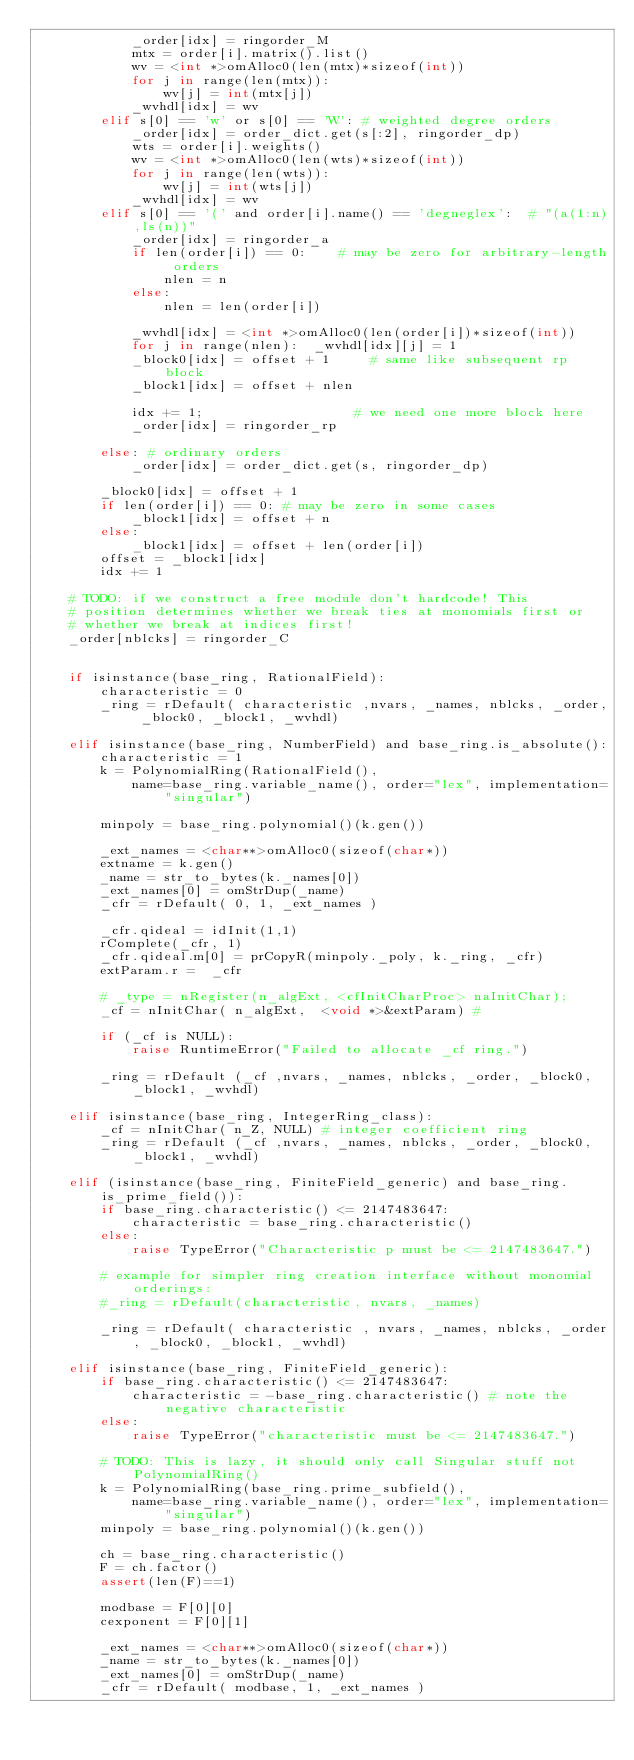<code> <loc_0><loc_0><loc_500><loc_500><_Cython_>            _order[idx] = ringorder_M
            mtx = order[i].matrix().list()
            wv = <int *>omAlloc0(len(mtx)*sizeof(int))
            for j in range(len(mtx)):
                wv[j] = int(mtx[j])
            _wvhdl[idx] = wv
        elif s[0] == 'w' or s[0] == 'W': # weighted degree orders
            _order[idx] = order_dict.get(s[:2], ringorder_dp)
            wts = order[i].weights()
            wv = <int *>omAlloc0(len(wts)*sizeof(int))
            for j in range(len(wts)):
                wv[j] = int(wts[j])
            _wvhdl[idx] = wv
        elif s[0] == '(' and order[i].name() == 'degneglex':  # "(a(1:n),ls(n))"
            _order[idx] = ringorder_a
            if len(order[i]) == 0:    # may be zero for arbitrary-length orders
                nlen = n
            else:
                nlen = len(order[i])

            _wvhdl[idx] = <int *>omAlloc0(len(order[i])*sizeof(int))
            for j in range(nlen):  _wvhdl[idx][j] = 1
            _block0[idx] = offset + 1     # same like subsequent rp block
            _block1[idx] = offset + nlen

            idx += 1;                   # we need one more block here
            _order[idx] = ringorder_rp

        else: # ordinary orders
            _order[idx] = order_dict.get(s, ringorder_dp)

        _block0[idx] = offset + 1
        if len(order[i]) == 0: # may be zero in some cases
            _block1[idx] = offset + n
        else:
            _block1[idx] = offset + len(order[i])
        offset = _block1[idx]
        idx += 1

    # TODO: if we construct a free module don't hardcode! This
    # position determines whether we break ties at monomials first or
    # whether we break at indices first!
    _order[nblcks] = ringorder_C


    if isinstance(base_ring, RationalField):
        characteristic = 0
        _ring = rDefault( characteristic ,nvars, _names, nblcks, _order, _block0, _block1, _wvhdl)

    elif isinstance(base_ring, NumberField) and base_ring.is_absolute():
        characteristic = 1
        k = PolynomialRing(RationalField(),
            name=base_ring.variable_name(), order="lex", implementation="singular")

        minpoly = base_ring.polynomial()(k.gen())

        _ext_names = <char**>omAlloc0(sizeof(char*))
        extname = k.gen()
        _name = str_to_bytes(k._names[0])
        _ext_names[0] = omStrDup(_name)
        _cfr = rDefault( 0, 1, _ext_names )

        _cfr.qideal = idInit(1,1)
        rComplete(_cfr, 1)
        _cfr.qideal.m[0] = prCopyR(minpoly._poly, k._ring, _cfr)
        extParam.r =  _cfr

        # _type = nRegister(n_algExt, <cfInitCharProc> naInitChar);
        _cf = nInitChar( n_algExt,  <void *>&extParam) #

        if (_cf is NULL):
            raise RuntimeError("Failed to allocate _cf ring.")

        _ring = rDefault (_cf ,nvars, _names, nblcks, _order, _block0, _block1, _wvhdl)

    elif isinstance(base_ring, IntegerRing_class):
        _cf = nInitChar( n_Z, NULL) # integer coefficient ring
        _ring = rDefault (_cf ,nvars, _names, nblcks, _order, _block0, _block1, _wvhdl)

    elif (isinstance(base_ring, FiniteField_generic) and base_ring.is_prime_field()):
        if base_ring.characteristic() <= 2147483647:
            characteristic = base_ring.characteristic()
        else:
            raise TypeError("Characteristic p must be <= 2147483647.")

        # example for simpler ring creation interface without monomial orderings:
        #_ring = rDefault(characteristic, nvars, _names)

        _ring = rDefault( characteristic , nvars, _names, nblcks, _order, _block0, _block1, _wvhdl)

    elif isinstance(base_ring, FiniteField_generic):
        if base_ring.characteristic() <= 2147483647:
            characteristic = -base_ring.characteristic() # note the negative characteristic
        else:
            raise TypeError("characteristic must be <= 2147483647.")

        # TODO: This is lazy, it should only call Singular stuff not PolynomialRing()
        k = PolynomialRing(base_ring.prime_subfield(),
            name=base_ring.variable_name(), order="lex", implementation="singular")
        minpoly = base_ring.polynomial()(k.gen())

        ch = base_ring.characteristic()
        F = ch.factor()
        assert(len(F)==1)

        modbase = F[0][0]
        cexponent = F[0][1]

        _ext_names = <char**>omAlloc0(sizeof(char*))
        _name = str_to_bytes(k._names[0])
        _ext_names[0] = omStrDup(_name)
        _cfr = rDefault( modbase, 1, _ext_names )
</code> 